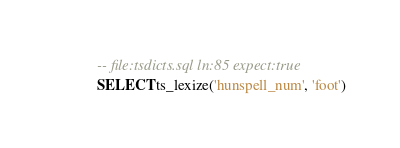Convert code to text. <code><loc_0><loc_0><loc_500><loc_500><_SQL_>-- file:tsdicts.sql ln:85 expect:true
SELECT ts_lexize('hunspell_num', 'foot')
</code> 